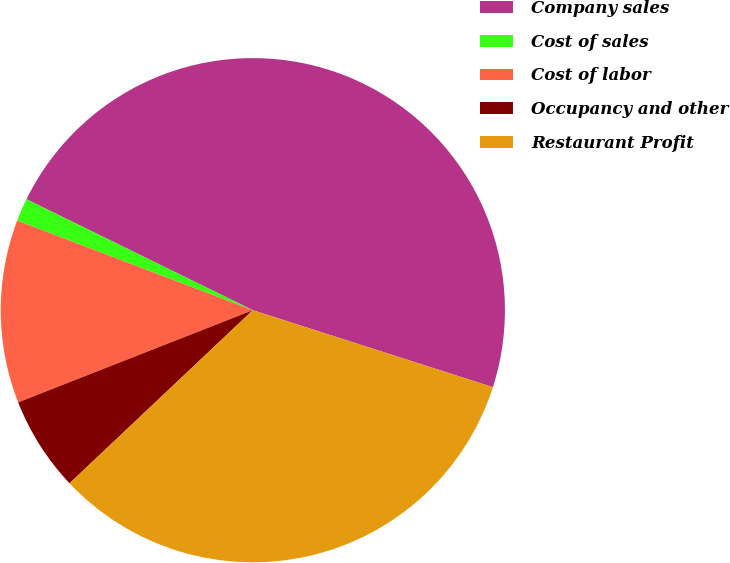Convert chart to OTSL. <chart><loc_0><loc_0><loc_500><loc_500><pie_chart><fcel>Company sales<fcel>Cost of sales<fcel>Cost of labor<fcel>Occupancy and other<fcel>Restaurant Profit<nl><fcel>47.69%<fcel>1.47%<fcel>11.74%<fcel>6.09%<fcel>33.02%<nl></chart> 